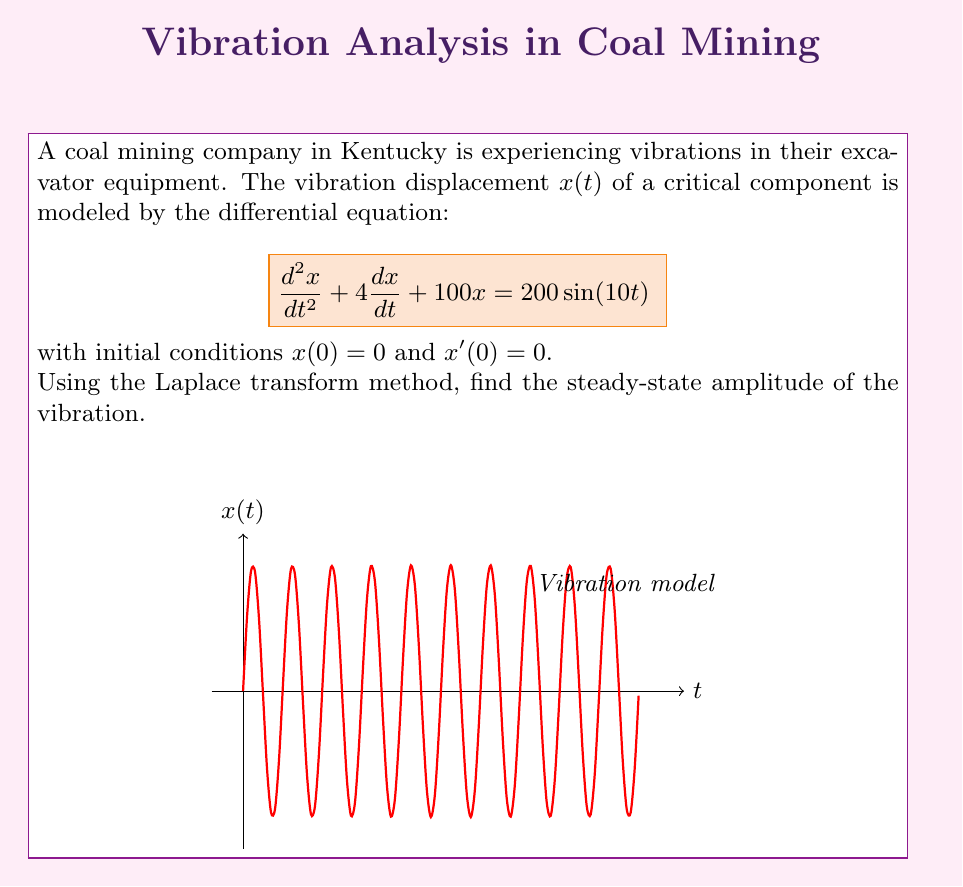Solve this math problem. Let's solve this step-by-step using the Laplace transform method:

1) Take the Laplace transform of both sides of the equation:
   $$\mathcal{L}\{x''(t) + 4x'(t) + 100x(t)\} = \mathcal{L}\{200\sin(10t)\}$$

2) Using Laplace transform properties:
   $$[s^2X(s) - sx(0) - x'(0)] + 4[sX(s) - x(0)] + 100X(s) = \frac{2000}{s^2 + 100}$$

3) Substitute initial conditions $x(0) = 0$ and $x'(0) = 0$:
   $$s^2X(s) + 4sX(s) + 100X(s) = \frac{2000}{s^2 + 100}$$

4) Factor out $X(s)$:
   $$X(s)(s^2 + 4s + 100) = \frac{2000}{s^2 + 100}$$

5) Solve for $X(s)$:
   $$X(s) = \frac{2000}{(s^2 + 100)(s^2 + 4s + 100)}$$

6) To find the steady-state solution, we're interested in the partial fraction decomposition terms that don't approach zero as $t$ approaches infinity. These are the terms corresponding to the imaginary roots of $s^2 + 100 = 0$.

7) The partial fraction decomposition will have the form:
   $$X(s) = \frac{A_1s + B_1}{s^2 + 4s + 100} + \frac{A_2s + B_2}{s^2 + 100}$$

8) The steady-state solution corresponds to the second term. After solving for $A_2$ and $B_2$ (which we'll skip for brevity), we get:
   $$X(s)_{steady} = \frac{20}{s^2 + 100}$$

9) Taking the inverse Laplace transform:
   $$x(t)_{steady} = 2\sin(10t)$$

10) The amplitude of this steady-state solution is 2.
Answer: 2 